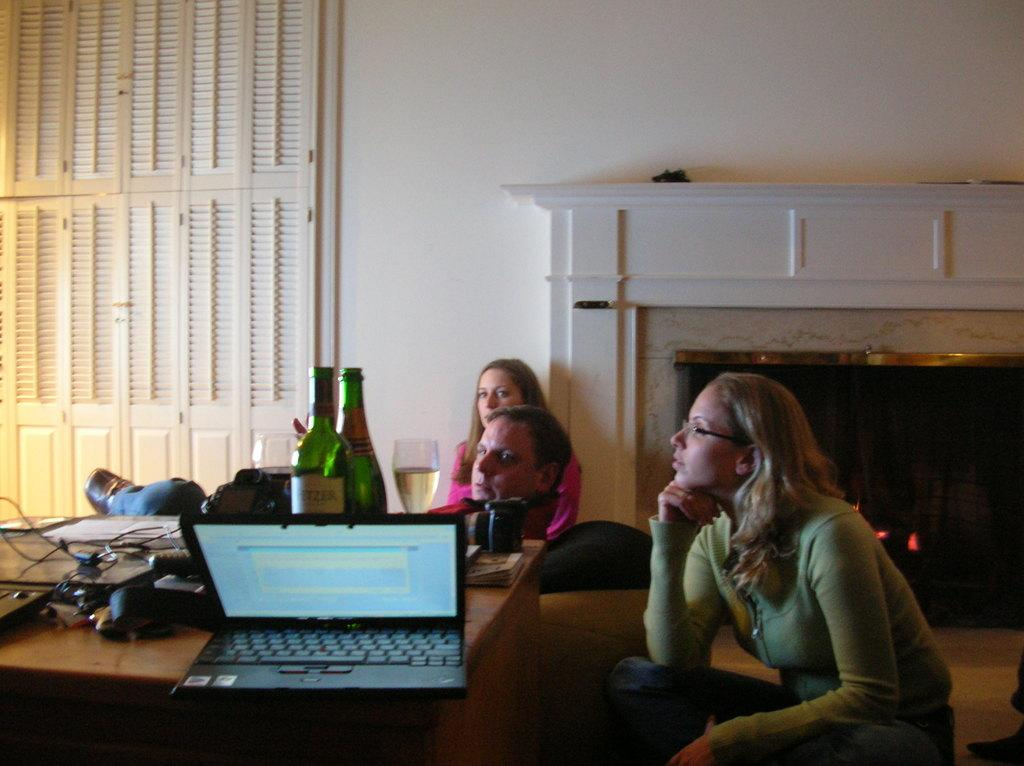How many people are sitting on the floor in the image? There are three persons sitting on the floor. What objects can be seen on the table in the image? There are bottles, glasses, a laptop, and books on the table. What type of furniture is present in the image? There is a table and a fireplace in the image. What type of rock can be seen in the image? There is no rock present in the image. Can you describe the wren perched on the laptop in the image? There is no wren present in the image; it is a laptop on the table. 